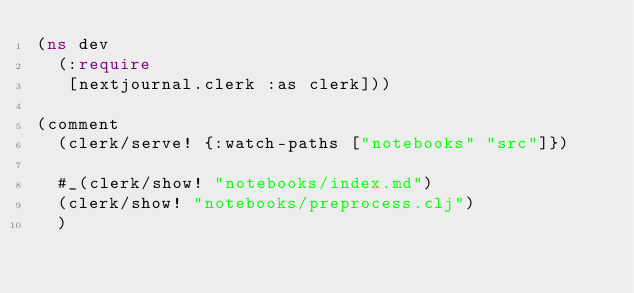Convert code to text. <code><loc_0><loc_0><loc_500><loc_500><_Clojure_>(ns dev
  (:require
   [nextjournal.clerk :as clerk]))

(comment
  (clerk/serve! {:watch-paths ["notebooks" "src"]})

  #_(clerk/show! "notebooks/index.md")
  (clerk/show! "notebooks/preprocess.clj")
  )
</code> 